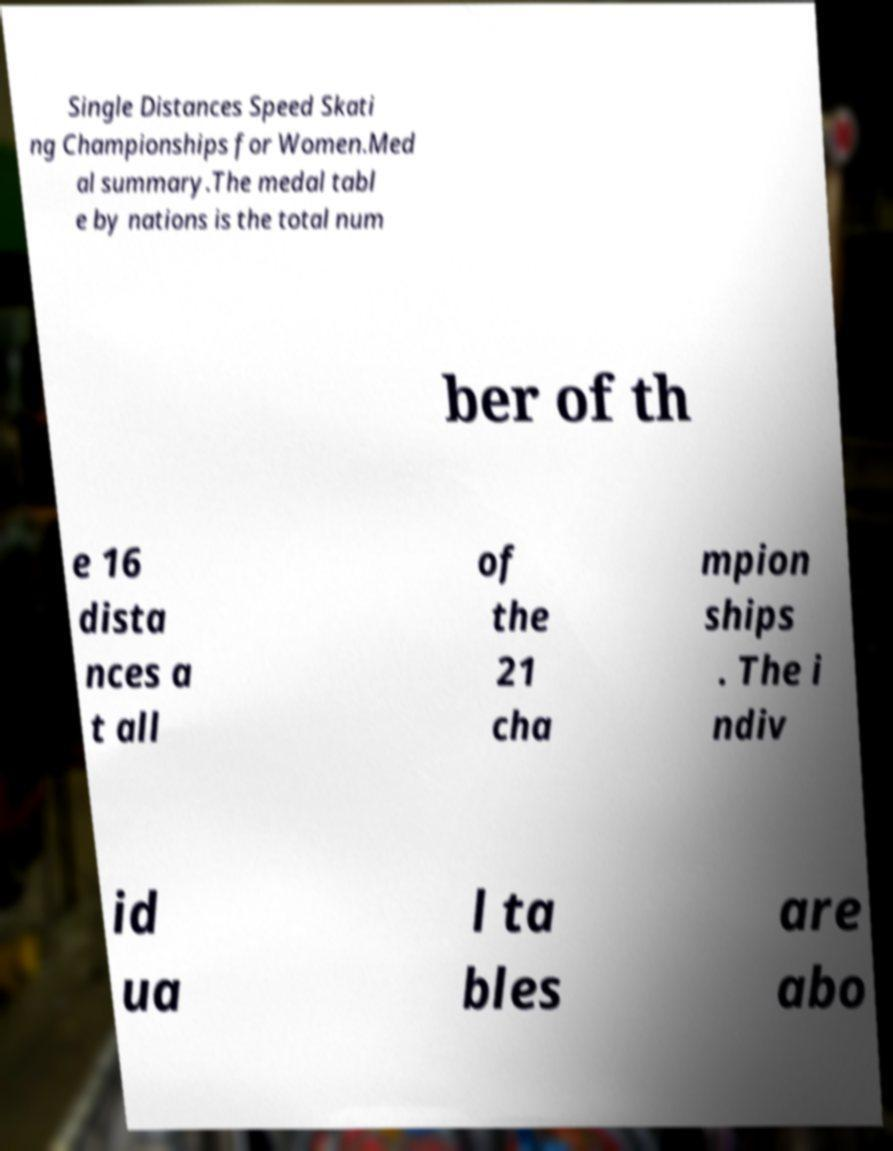Can you read and provide the text displayed in the image?This photo seems to have some interesting text. Can you extract and type it out for me? Single Distances Speed Skati ng Championships for Women.Med al summary.The medal tabl e by nations is the total num ber of th e 16 dista nces a t all of the 21 cha mpion ships . The i ndiv id ua l ta bles are abo 